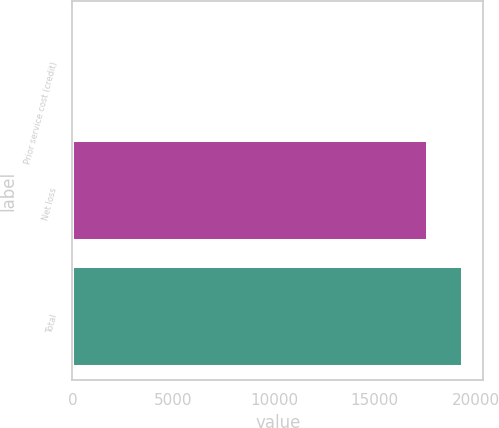Convert chart to OTSL. <chart><loc_0><loc_0><loc_500><loc_500><bar_chart><fcel>Prior service cost (credit)<fcel>Net loss<fcel>Total<nl><fcel>77<fcel>17643<fcel>19407.3<nl></chart> 